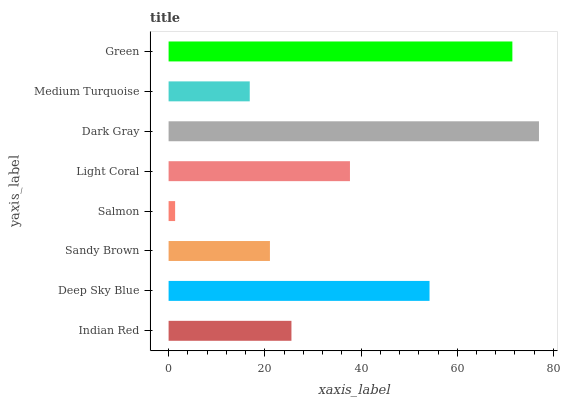Is Salmon the minimum?
Answer yes or no. Yes. Is Dark Gray the maximum?
Answer yes or no. Yes. Is Deep Sky Blue the minimum?
Answer yes or no. No. Is Deep Sky Blue the maximum?
Answer yes or no. No. Is Deep Sky Blue greater than Indian Red?
Answer yes or no. Yes. Is Indian Red less than Deep Sky Blue?
Answer yes or no. Yes. Is Indian Red greater than Deep Sky Blue?
Answer yes or no. No. Is Deep Sky Blue less than Indian Red?
Answer yes or no. No. Is Light Coral the high median?
Answer yes or no. Yes. Is Indian Red the low median?
Answer yes or no. Yes. Is Medium Turquoise the high median?
Answer yes or no. No. Is Medium Turquoise the low median?
Answer yes or no. No. 